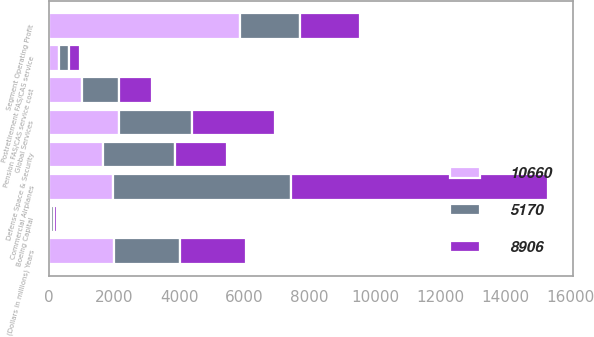Convert chart to OTSL. <chart><loc_0><loc_0><loc_500><loc_500><stacked_bar_chart><ecel><fcel>(Dollars in millions) Years<fcel>Commercial Airplanes<fcel>Defense Space & Security<fcel>Global Services<fcel>Boeing Capital<fcel>Segment Operating Profit<fcel>Pension FAS/CAS service cost<fcel>Postretirement FAS/CAS service<nl><fcel>8906<fcel>2018<fcel>7879<fcel>1594<fcel>2522<fcel>79<fcel>1829.5<fcel>1005<fcel>322<nl><fcel>5170<fcel>2017<fcel>5452<fcel>2193<fcel>2246<fcel>114<fcel>1829.5<fcel>1127<fcel>311<nl><fcel>10660<fcel>2016<fcel>1981<fcel>1678<fcel>2159<fcel>59<fcel>5877<fcel>1029<fcel>328<nl></chart> 